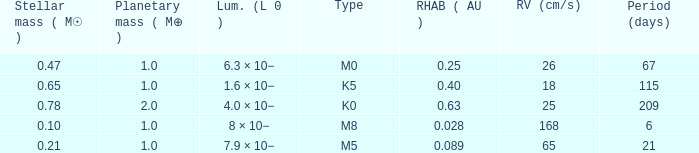What is the highest planetary mass having an RV (cm/s) of 65 and a Period (days) less than 21? None. 